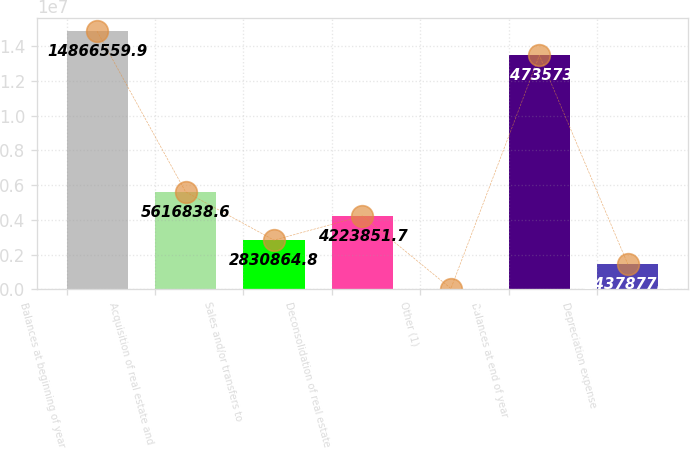<chart> <loc_0><loc_0><loc_500><loc_500><bar_chart><fcel>Balances at beginning of year<fcel>Acquisition of real estate and<fcel>Sales and/or transfers to<fcel>Deconsolidation of real estate<fcel>Other (1)<fcel>Balances at end of year<fcel>Depreciation expense<nl><fcel>1.48666e+07<fcel>5.61684e+06<fcel>2.83086e+06<fcel>4.22385e+06<fcel>44891<fcel>1.34736e+07<fcel>1.43788e+06<nl></chart> 